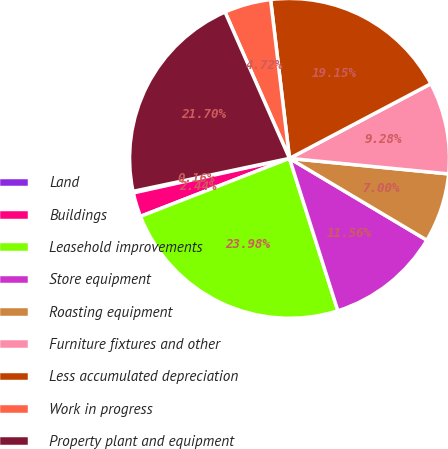Convert chart. <chart><loc_0><loc_0><loc_500><loc_500><pie_chart><fcel>Land<fcel>Buildings<fcel>Leasehold improvements<fcel>Store equipment<fcel>Roasting equipment<fcel>Furniture fixtures and other<fcel>Less accumulated depreciation<fcel>Work in progress<fcel>Property plant and equipment<nl><fcel>0.16%<fcel>2.44%<fcel>23.98%<fcel>11.56%<fcel>7.0%<fcel>9.28%<fcel>19.15%<fcel>4.72%<fcel>21.7%<nl></chart> 